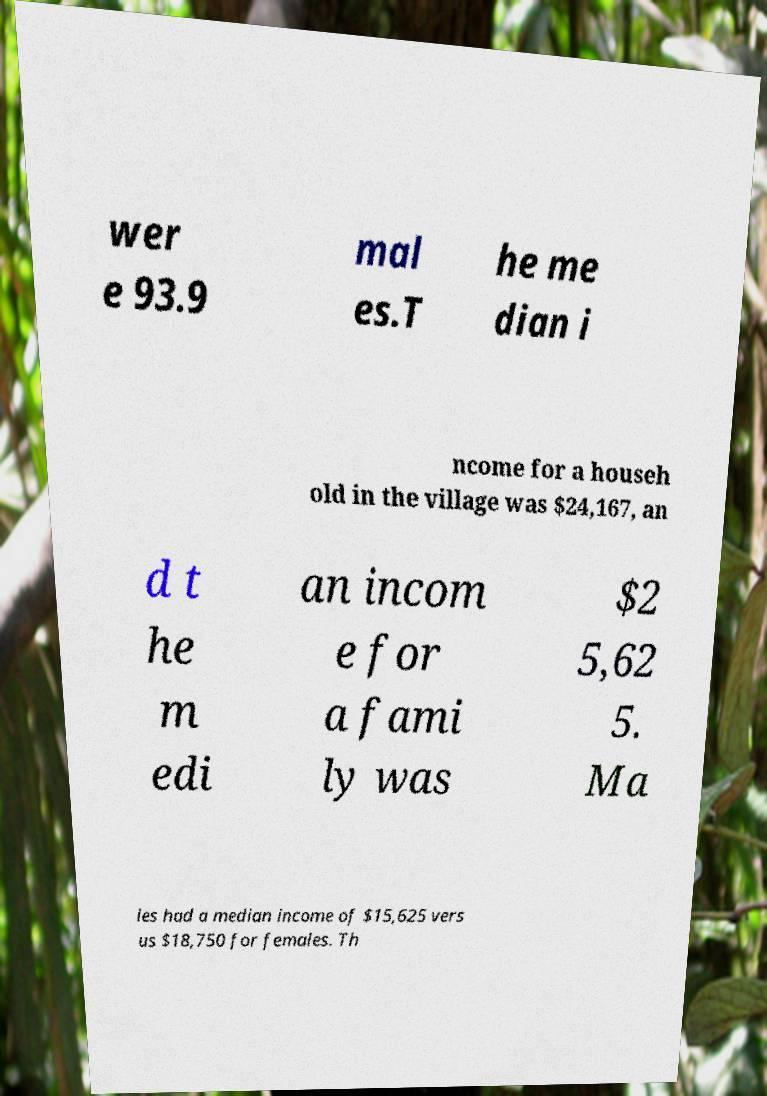Please identify and transcribe the text found in this image. wer e 93.9 mal es.T he me dian i ncome for a househ old in the village was $24,167, an d t he m edi an incom e for a fami ly was $2 5,62 5. Ma les had a median income of $15,625 vers us $18,750 for females. Th 